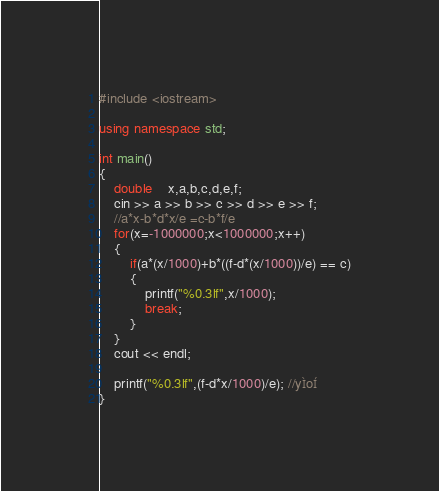Convert code to text. <code><loc_0><loc_0><loc_500><loc_500><_C++_>#include <iostream>

using namespace std;

int main()
{
	double	x,a,b,c,d,e,f;
	cin >> a >> b >> c >> d >> e >> f;
	//a*x-b*d*x/e =c-b*f/e
	for(x=-1000000;x<1000000;x++)
	{
		if(a*(x/1000)+b*((f-d*(x/1000))/e) == c)
		{
			printf("%0.3lf",x/1000);
			break;
		}
	}
	cout << endl;
	
	printf("%0.3lf",(f-d*x/1000)/e); //yÌoÍ
}</code> 